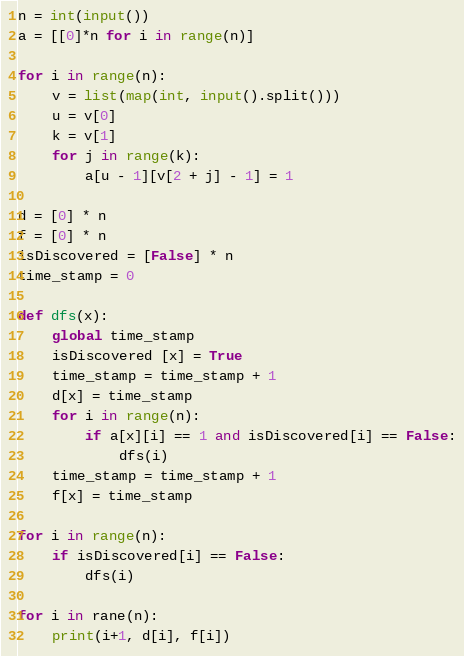<code> <loc_0><loc_0><loc_500><loc_500><_Python_>n = int(input())
a = [[0]*n for i in range(n)]
  
for i in range(n):
    v = list(map(int, input().split()))
    u = v[0]
    k = v[1]
    for j in range(k):
        a[u - 1][v[2 + j] - 1] = 1

d = [0] * n
f = [0] * n
isDiscovered = [False] * n
time_stamp = 0

def dfs(x):
    global time_stamp
    isDiscovered [x] = True
    time_stamp = time_stamp + 1
    d[x] = time_stamp
    for i in range(n):
        if a[x][i] == 1 and isDiscovered[i] == False:
            dfs(i)
    time_stamp = time_stamp + 1
    f[x] = time_stamp

for i in range(n):
    if isDiscovered[i] == False:
        dfs(i)

for i in rane(n):
    print(i+1, d[i], f[i])</code> 